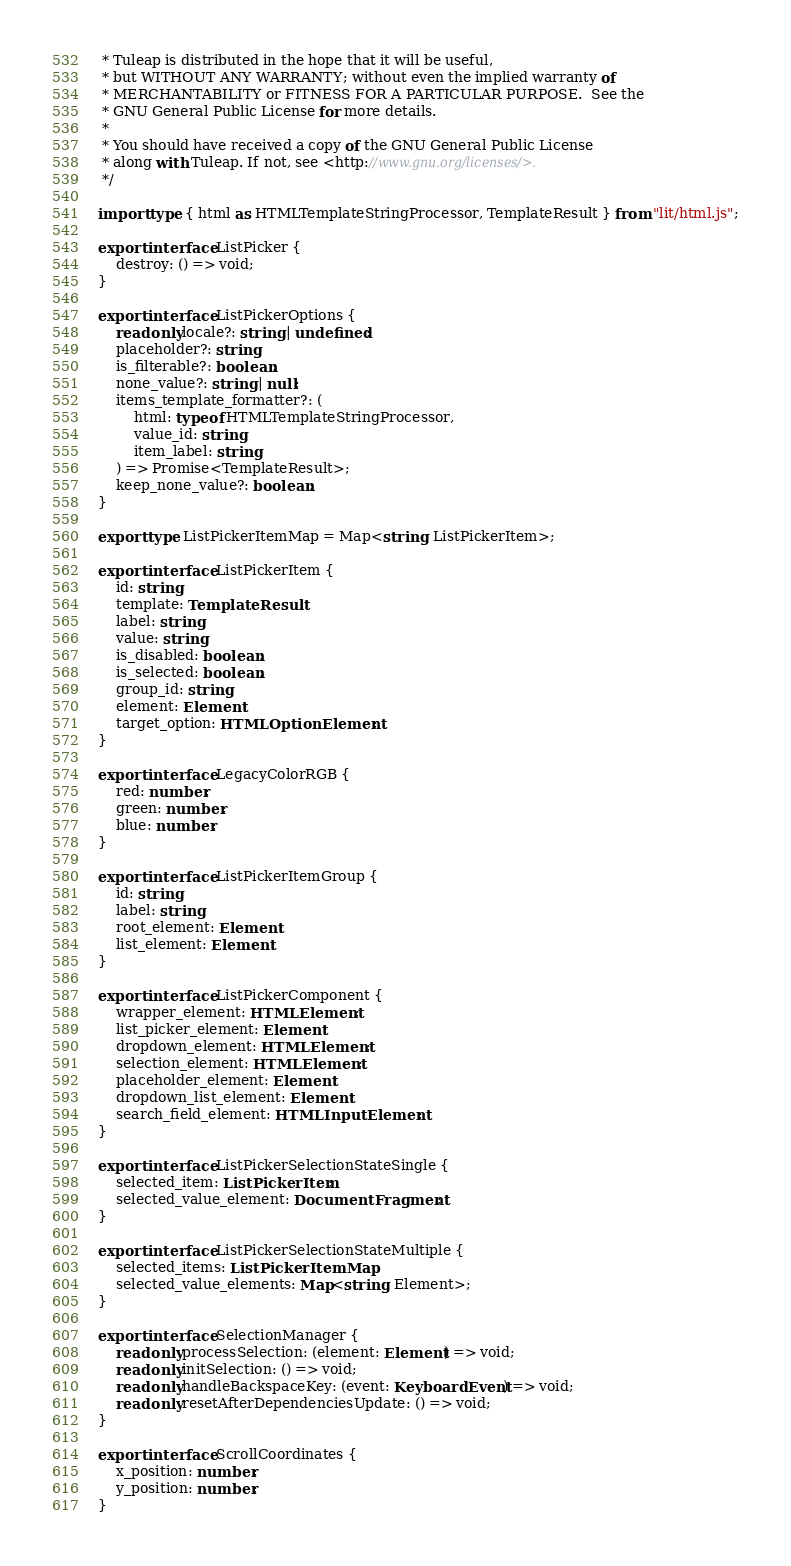Convert code to text. <code><loc_0><loc_0><loc_500><loc_500><_TypeScript_> * Tuleap is distributed in the hope that it will be useful,
 * but WITHOUT ANY WARRANTY; without even the implied warranty of
 * MERCHANTABILITY or FITNESS FOR A PARTICULAR PURPOSE.  See the
 * GNU General Public License for more details.
 *
 * You should have received a copy of the GNU General Public License
 * along with Tuleap. If not, see <http://www.gnu.org/licenses/>.
 */

import type { html as HTMLTemplateStringProcessor, TemplateResult } from "lit/html.js";

export interface ListPicker {
    destroy: () => void;
}

export interface ListPickerOptions {
    readonly locale?: string | undefined;
    placeholder?: string;
    is_filterable?: boolean;
    none_value?: string | null;
    items_template_formatter?: (
        html: typeof HTMLTemplateStringProcessor,
        value_id: string,
        item_label: string
    ) => Promise<TemplateResult>;
    keep_none_value?: boolean;
}

export type ListPickerItemMap = Map<string, ListPickerItem>;

export interface ListPickerItem {
    id: string;
    template: TemplateResult;
    label: string;
    value: string;
    is_disabled: boolean;
    is_selected: boolean;
    group_id: string;
    element: Element;
    target_option: HTMLOptionElement;
}

export interface LegacyColorRGB {
    red: number;
    green: number;
    blue: number;
}

export interface ListPickerItemGroup {
    id: string;
    label: string;
    root_element: Element;
    list_element: Element;
}

export interface ListPickerComponent {
    wrapper_element: HTMLElement;
    list_picker_element: Element;
    dropdown_element: HTMLElement;
    selection_element: HTMLElement;
    placeholder_element: Element;
    dropdown_list_element: Element;
    search_field_element: HTMLInputElement;
}

export interface ListPickerSelectionStateSingle {
    selected_item: ListPickerItem;
    selected_value_element: DocumentFragment;
}

export interface ListPickerSelectionStateMultiple {
    selected_items: ListPickerItemMap;
    selected_value_elements: Map<string, Element>;
}

export interface SelectionManager {
    readonly processSelection: (element: Element) => void;
    readonly initSelection: () => void;
    readonly handleBackspaceKey: (event: KeyboardEvent) => void;
    readonly resetAfterDependenciesUpdate: () => void;
}

export interface ScrollCoordinates {
    x_position: number;
    y_position: number;
}
</code> 